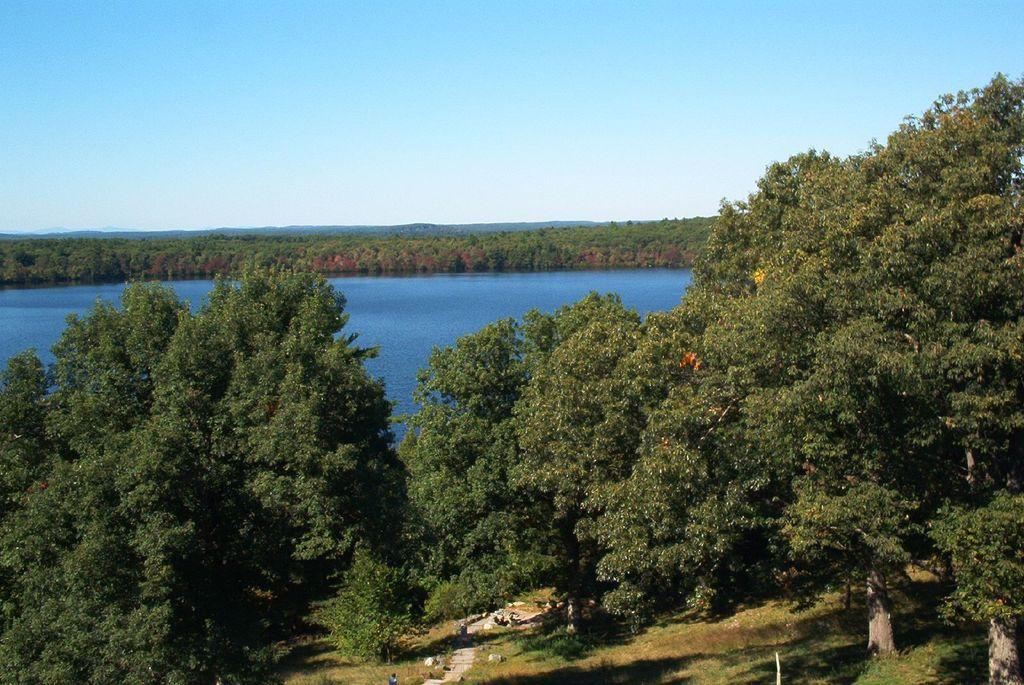What type of vegetation can be seen in the image? There are many trees in the image. What type of ground cover is visible in the image? There is grass visible in the image. What natural feature is present in the image? There is water visible in the image. What part of the natural environment is visible in the image? There is a sky visible in the image. What type of material is present in the image? There are stones present in the image. What color is the scarf that is blowing in the wind in the image? There is no scarf or wind present in the image. Can you describe the sidewalk in the image? There is no sidewalk present in the image. 